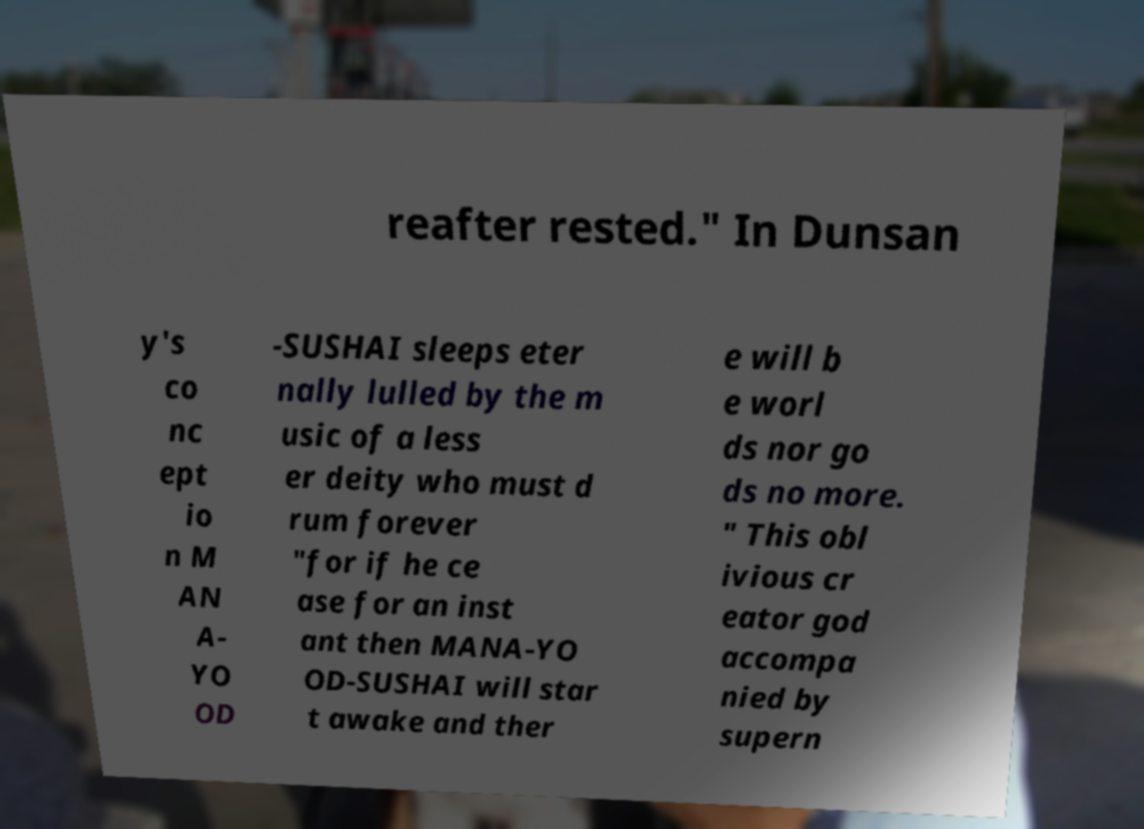Could you extract and type out the text from this image? reafter rested." In Dunsan y's co nc ept io n M AN A- YO OD -SUSHAI sleeps eter nally lulled by the m usic of a less er deity who must d rum forever "for if he ce ase for an inst ant then MANA-YO OD-SUSHAI will star t awake and ther e will b e worl ds nor go ds no more. " This obl ivious cr eator god accompa nied by supern 